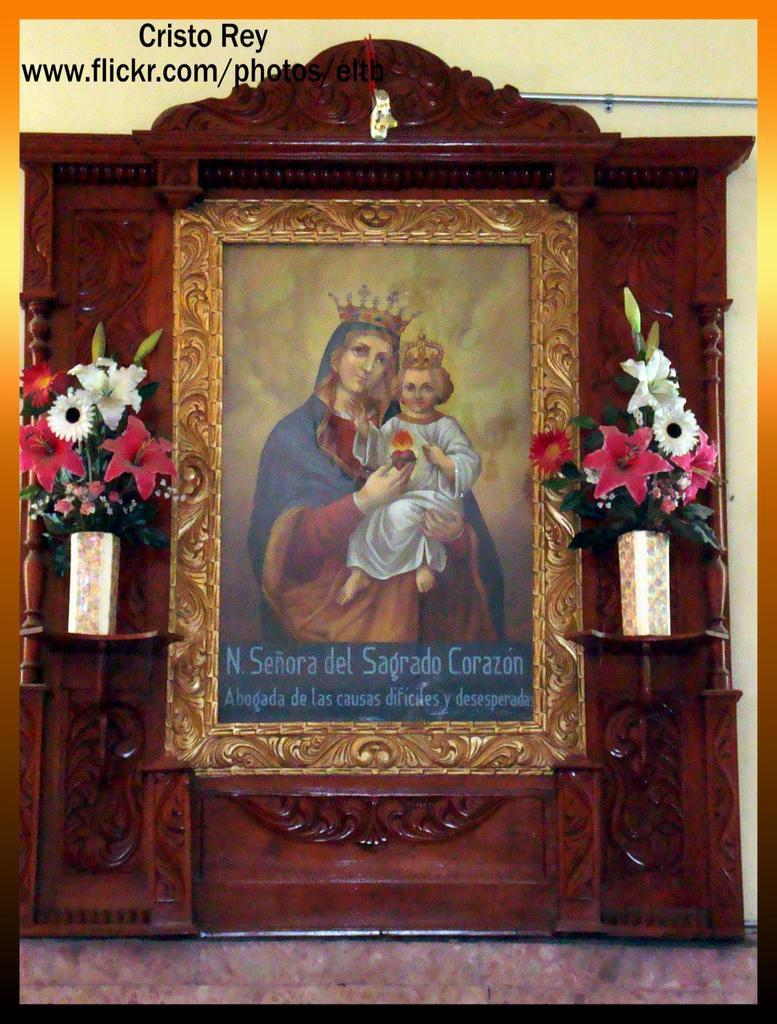Provide a one-sentence caption for the provided image. A picture of Mary and Christ with a flickr address above it. 